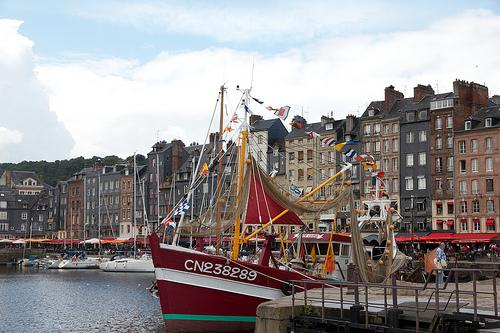Question: where are the buildings?
Choices:
A. Beside the water.
B. Downtown.
C. By the bridge.
D. Over the hill.
Answer with the letter. Answer: A Question: what is beside the red boat?
Choices:
A. Dock.
B. The  blue Coast Guard cutter.
C. The white yacht.
D. The platform.
Answer with the letter. Answer: A Question: what color are the stripes on the red boat?
Choices:
A. Blue.
B. Black.
C. Green and white.
D. Grey.
Answer with the letter. Answer: C Question: where are all the colorful little flags?
Choices:
A. On the dock.
B. Up the flagpole.
C. In the drink.
D. Over the boat.
Answer with the letter. Answer: D Question: what letters and numbers are on the red ship?
Choices:
A. CN238289.
B. Ss314.
C. Uss225.
D. Princess69.
Answer with the letter. Answer: A 